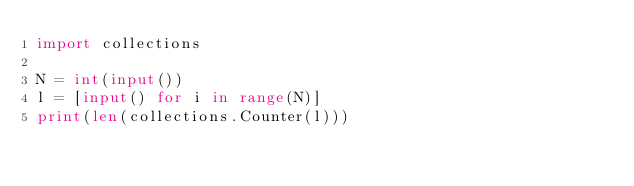Convert code to text. <code><loc_0><loc_0><loc_500><loc_500><_Python_>import collections

N = int(input())
l = [input() for i in range(N)]
print(len(collections.Counter(l)))
</code> 